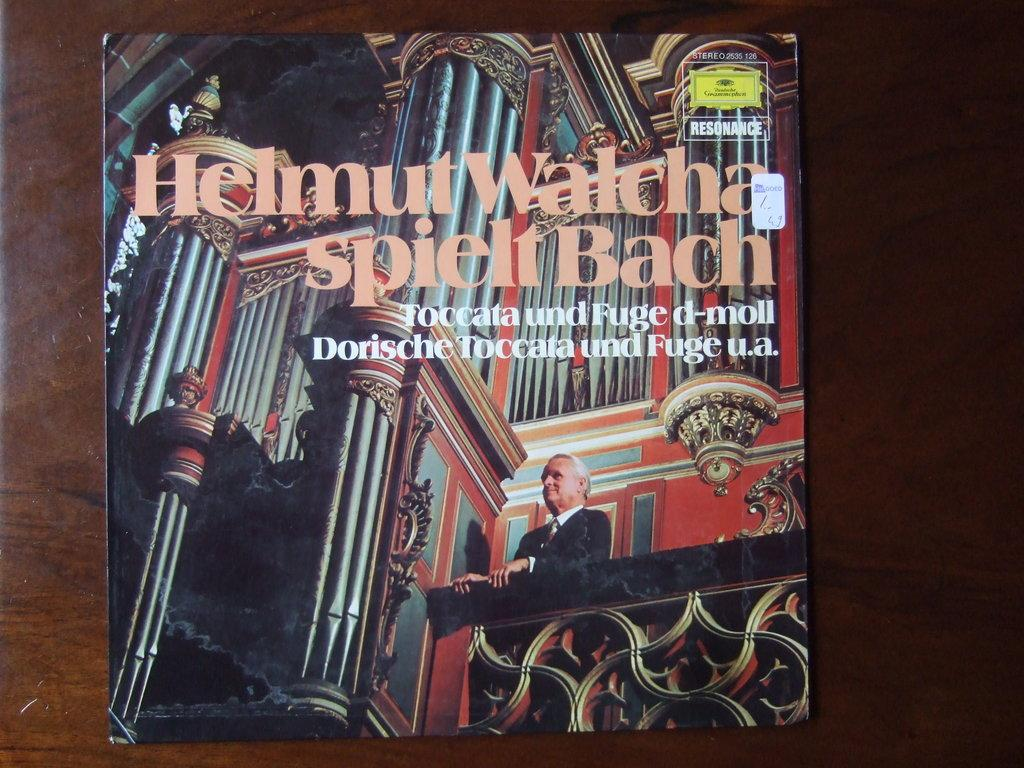What object can be seen in the image? There is a book in the image. Where is the book located? The book is on a table. What type of lip can be seen on the book in the image? There is no lip present on the book in the image. 